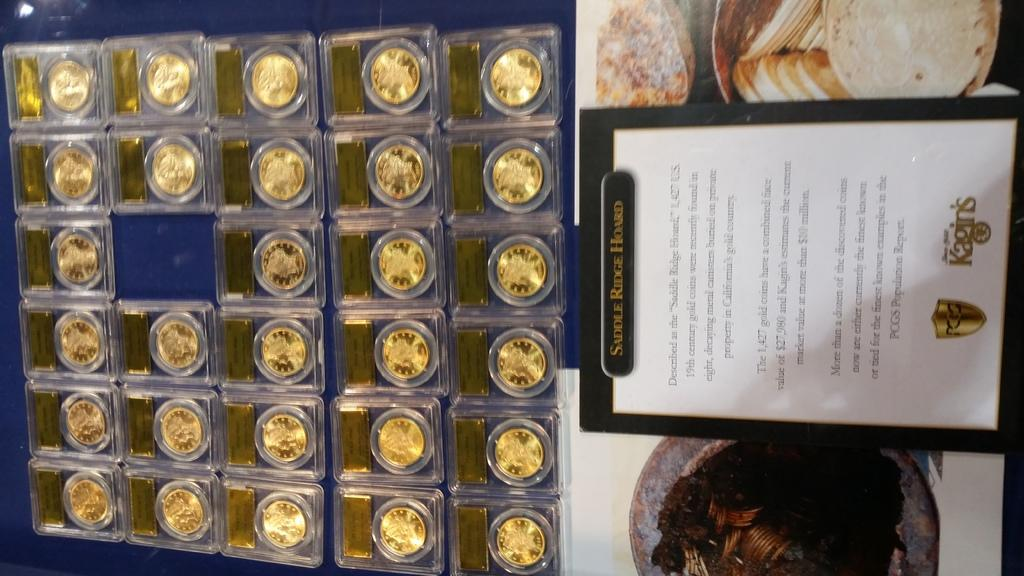<image>
Offer a succinct explanation of the picture presented. Saddle ridge Hoard in a picture frame that includes coins 